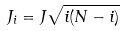<formula> <loc_0><loc_0><loc_500><loc_500>J _ { i } = J \sqrt { i ( N - i ) }</formula> 